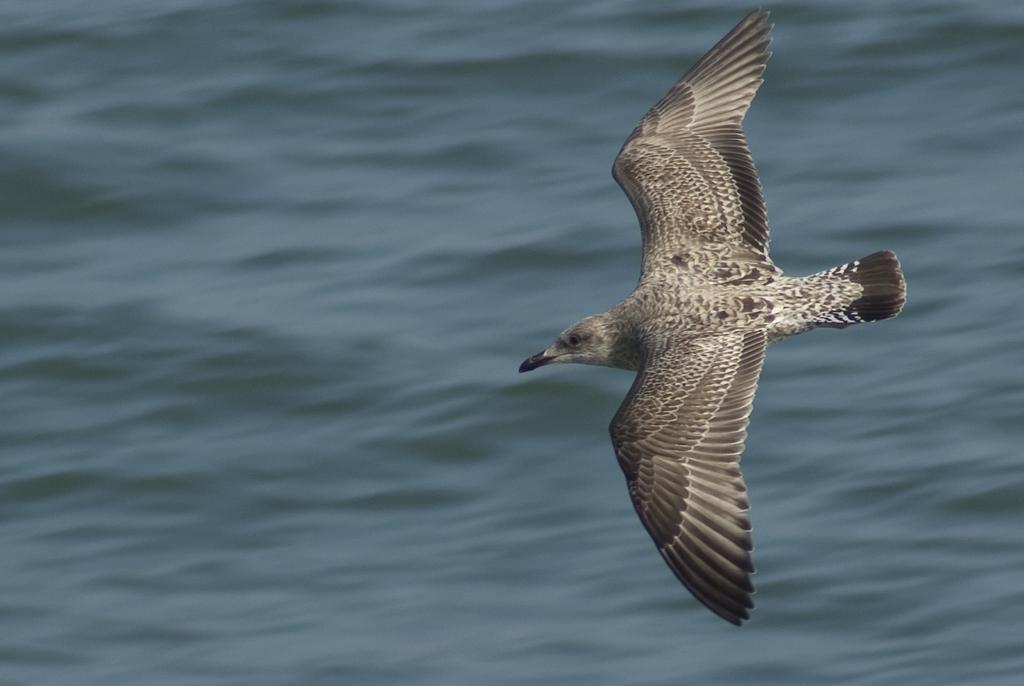What is the main subject in the foreground of the image? There is a bird flying in the foreground of the image. Can you describe the bird's location in relation to the image? The bird is in the foreground of the image. What can be seen in the background of the image? There is water visible in the background of the image. How many rabbits can be seen hopping in the water in the image? There are no rabbits present in the image, and they are not hopping in the water. Can you tell me the color of the donkey's fur in the image? There is no donkey present in the image, so we cannot determine the color of its fur. 